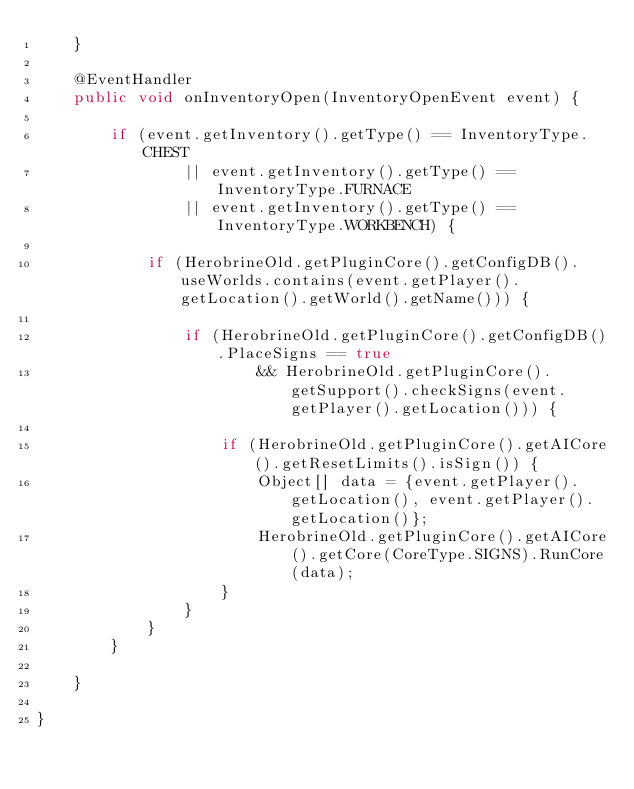Convert code to text. <code><loc_0><loc_0><loc_500><loc_500><_Java_>    }

    @EventHandler
    public void onInventoryOpen(InventoryOpenEvent event) {

        if (event.getInventory().getType() == InventoryType.CHEST
                || event.getInventory().getType() == InventoryType.FURNACE
                || event.getInventory().getType() == InventoryType.WORKBENCH) {

            if (HerobrineOld.getPluginCore().getConfigDB().useWorlds.contains(event.getPlayer().getLocation().getWorld().getName())) {

                if (HerobrineOld.getPluginCore().getConfigDB().PlaceSigns == true
                        && HerobrineOld.getPluginCore().getSupport().checkSigns(event.getPlayer().getLocation())) {

                    if (HerobrineOld.getPluginCore().getAICore().getResetLimits().isSign()) {
                        Object[] data = {event.getPlayer().getLocation(), event.getPlayer().getLocation()};
                        HerobrineOld.getPluginCore().getAICore().getCore(CoreType.SIGNS).RunCore(data);
                    }
                }
            }
        }

    }

}
</code> 